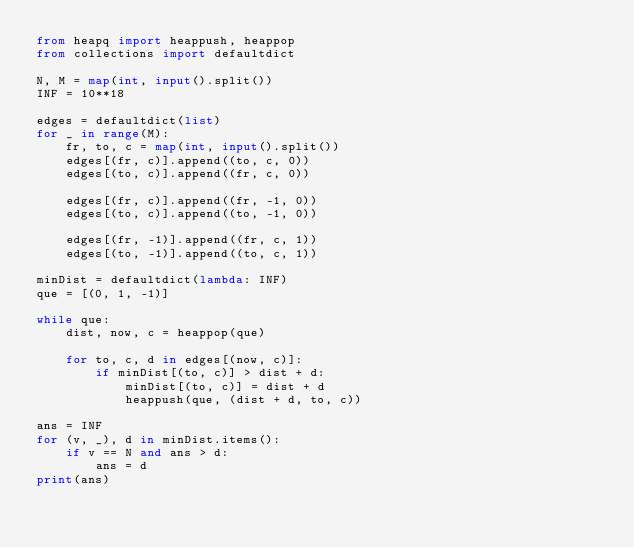Convert code to text. <code><loc_0><loc_0><loc_500><loc_500><_Python_>from heapq import heappush, heappop
from collections import defaultdict

N, M = map(int, input().split())
INF = 10**18

edges = defaultdict(list)
for _ in range(M):
    fr, to, c = map(int, input().split())
    edges[(fr, c)].append((to, c, 0))
    edges[(to, c)].append((fr, c, 0))

    edges[(fr, c)].append((fr, -1, 0))
    edges[(to, c)].append((to, -1, 0))

    edges[(fr, -1)].append((fr, c, 1))
    edges[(to, -1)].append((to, c, 1))

minDist = defaultdict(lambda: INF)
que = [(0, 1, -1)]

while que:
    dist, now, c = heappop(que)

    for to, c, d in edges[(now, c)]:
        if minDist[(to, c)] > dist + d:
            minDist[(to, c)] = dist + d
            heappush(que, (dist + d, to, c))

ans = INF
for (v, _), d in minDist.items():
    if v == N and ans > d:
        ans = d
print(ans)
</code> 